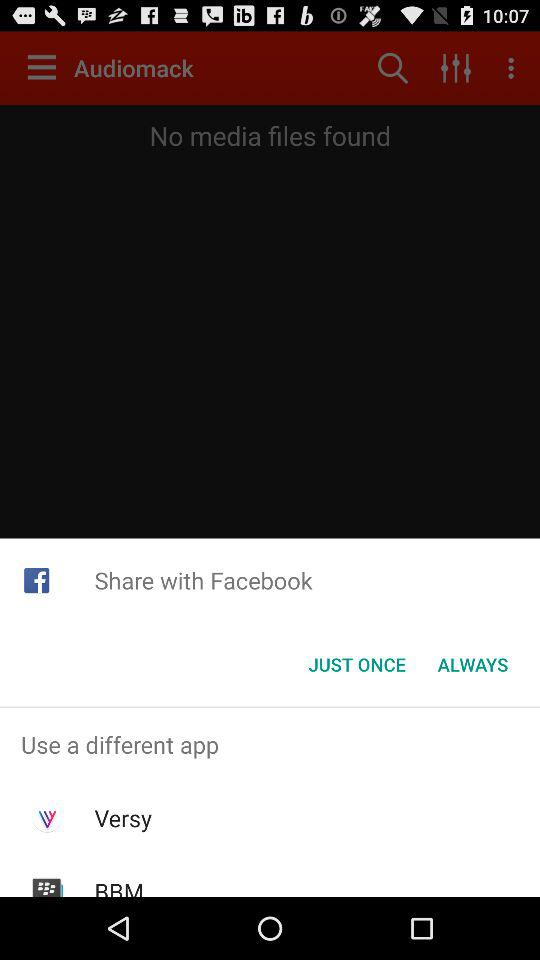What are the different applications that users can use to share the content? The applications are "Versy" and "BBM". 